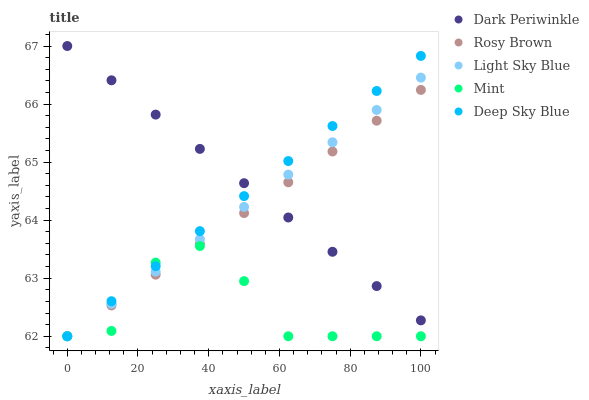Does Mint have the minimum area under the curve?
Answer yes or no. Yes. Does Dark Periwinkle have the maximum area under the curve?
Answer yes or no. Yes. Does Rosy Brown have the minimum area under the curve?
Answer yes or no. No. Does Rosy Brown have the maximum area under the curve?
Answer yes or no. No. Is Light Sky Blue the smoothest?
Answer yes or no. Yes. Is Mint the roughest?
Answer yes or no. Yes. Is Rosy Brown the smoothest?
Answer yes or no. No. Is Rosy Brown the roughest?
Answer yes or no. No. Does Deep Sky Blue have the lowest value?
Answer yes or no. Yes. Does Dark Periwinkle have the lowest value?
Answer yes or no. No. Does Dark Periwinkle have the highest value?
Answer yes or no. Yes. Does Rosy Brown have the highest value?
Answer yes or no. No. Is Mint less than Dark Periwinkle?
Answer yes or no. Yes. Is Dark Periwinkle greater than Mint?
Answer yes or no. Yes. Does Mint intersect Deep Sky Blue?
Answer yes or no. Yes. Is Mint less than Deep Sky Blue?
Answer yes or no. No. Is Mint greater than Deep Sky Blue?
Answer yes or no. No. Does Mint intersect Dark Periwinkle?
Answer yes or no. No. 